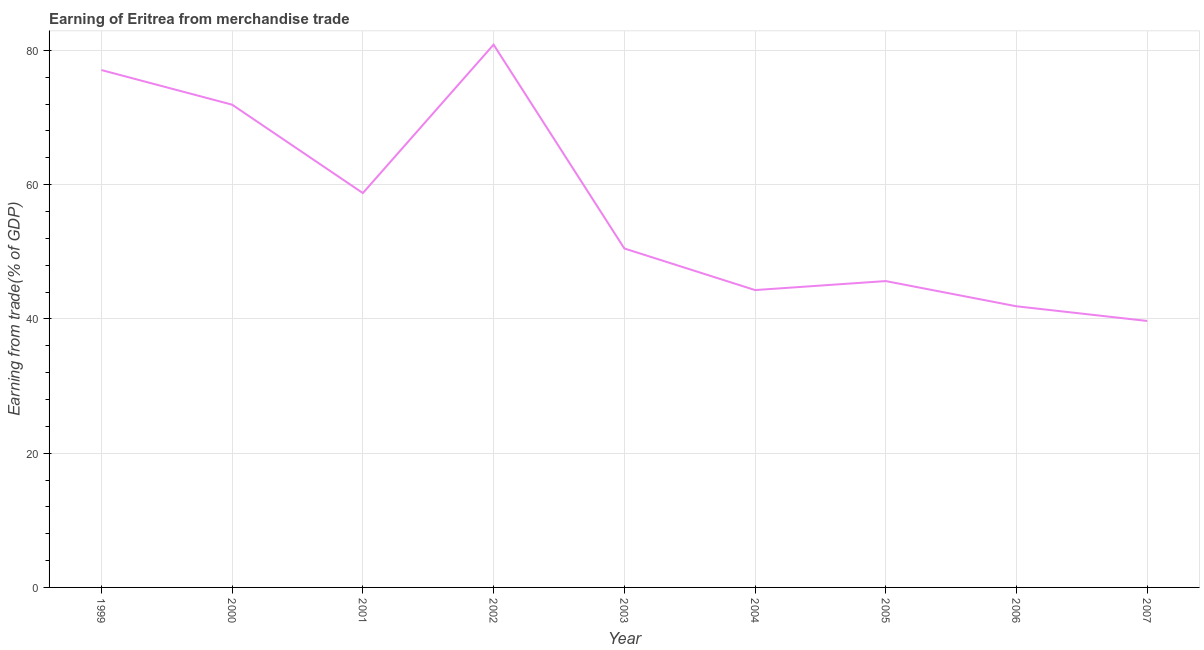What is the earning from merchandise trade in 2007?
Your response must be concise. 39.7. Across all years, what is the maximum earning from merchandise trade?
Keep it short and to the point. 80.86. Across all years, what is the minimum earning from merchandise trade?
Offer a very short reply. 39.7. What is the sum of the earning from merchandise trade?
Provide a short and direct response. 510.62. What is the difference between the earning from merchandise trade in 2003 and 2006?
Make the answer very short. 8.62. What is the average earning from merchandise trade per year?
Offer a very short reply. 56.74. What is the median earning from merchandise trade?
Offer a very short reply. 50.5. What is the ratio of the earning from merchandise trade in 2002 to that in 2005?
Give a very brief answer. 1.77. Is the earning from merchandise trade in 2000 less than that in 2006?
Make the answer very short. No. Is the difference between the earning from merchandise trade in 1999 and 2001 greater than the difference between any two years?
Provide a short and direct response. No. What is the difference between the highest and the second highest earning from merchandise trade?
Your answer should be compact. 3.79. Is the sum of the earning from merchandise trade in 2005 and 2007 greater than the maximum earning from merchandise trade across all years?
Provide a succinct answer. Yes. What is the difference between the highest and the lowest earning from merchandise trade?
Offer a terse response. 41.16. In how many years, is the earning from merchandise trade greater than the average earning from merchandise trade taken over all years?
Your response must be concise. 4. How many years are there in the graph?
Your answer should be compact. 9. What is the difference between two consecutive major ticks on the Y-axis?
Provide a succinct answer. 20. Are the values on the major ticks of Y-axis written in scientific E-notation?
Your answer should be very brief. No. Does the graph contain grids?
Your response must be concise. Yes. What is the title of the graph?
Provide a succinct answer. Earning of Eritrea from merchandise trade. What is the label or title of the X-axis?
Ensure brevity in your answer.  Year. What is the label or title of the Y-axis?
Provide a short and direct response. Earning from trade(% of GDP). What is the Earning from trade(% of GDP) in 1999?
Ensure brevity in your answer.  77.08. What is the Earning from trade(% of GDP) in 2000?
Your answer should be compact. 71.92. What is the Earning from trade(% of GDP) of 2001?
Offer a very short reply. 58.75. What is the Earning from trade(% of GDP) in 2002?
Keep it short and to the point. 80.86. What is the Earning from trade(% of GDP) of 2003?
Offer a very short reply. 50.5. What is the Earning from trade(% of GDP) of 2004?
Provide a short and direct response. 44.3. What is the Earning from trade(% of GDP) of 2005?
Make the answer very short. 45.64. What is the Earning from trade(% of GDP) in 2006?
Offer a terse response. 41.88. What is the Earning from trade(% of GDP) of 2007?
Offer a very short reply. 39.7. What is the difference between the Earning from trade(% of GDP) in 1999 and 2000?
Ensure brevity in your answer.  5.16. What is the difference between the Earning from trade(% of GDP) in 1999 and 2001?
Make the answer very short. 18.33. What is the difference between the Earning from trade(% of GDP) in 1999 and 2002?
Give a very brief answer. -3.79. What is the difference between the Earning from trade(% of GDP) in 1999 and 2003?
Your answer should be very brief. 26.58. What is the difference between the Earning from trade(% of GDP) in 1999 and 2004?
Make the answer very short. 32.78. What is the difference between the Earning from trade(% of GDP) in 1999 and 2005?
Your answer should be compact. 31.44. What is the difference between the Earning from trade(% of GDP) in 1999 and 2006?
Provide a succinct answer. 35.19. What is the difference between the Earning from trade(% of GDP) in 1999 and 2007?
Provide a short and direct response. 37.38. What is the difference between the Earning from trade(% of GDP) in 2000 and 2001?
Make the answer very short. 13.17. What is the difference between the Earning from trade(% of GDP) in 2000 and 2002?
Provide a succinct answer. -8.95. What is the difference between the Earning from trade(% of GDP) in 2000 and 2003?
Offer a terse response. 21.42. What is the difference between the Earning from trade(% of GDP) in 2000 and 2004?
Ensure brevity in your answer.  27.62. What is the difference between the Earning from trade(% of GDP) in 2000 and 2005?
Ensure brevity in your answer.  26.28. What is the difference between the Earning from trade(% of GDP) in 2000 and 2006?
Make the answer very short. 30.03. What is the difference between the Earning from trade(% of GDP) in 2000 and 2007?
Provide a short and direct response. 32.22. What is the difference between the Earning from trade(% of GDP) in 2001 and 2002?
Make the answer very short. -22.12. What is the difference between the Earning from trade(% of GDP) in 2001 and 2003?
Provide a short and direct response. 8.25. What is the difference between the Earning from trade(% of GDP) in 2001 and 2004?
Keep it short and to the point. 14.45. What is the difference between the Earning from trade(% of GDP) in 2001 and 2005?
Your answer should be very brief. 13.11. What is the difference between the Earning from trade(% of GDP) in 2001 and 2006?
Provide a succinct answer. 16.86. What is the difference between the Earning from trade(% of GDP) in 2001 and 2007?
Provide a short and direct response. 19.05. What is the difference between the Earning from trade(% of GDP) in 2002 and 2003?
Offer a very short reply. 30.37. What is the difference between the Earning from trade(% of GDP) in 2002 and 2004?
Ensure brevity in your answer.  36.56. What is the difference between the Earning from trade(% of GDP) in 2002 and 2005?
Ensure brevity in your answer.  35.22. What is the difference between the Earning from trade(% of GDP) in 2002 and 2006?
Make the answer very short. 38.98. What is the difference between the Earning from trade(% of GDP) in 2002 and 2007?
Provide a short and direct response. 41.16. What is the difference between the Earning from trade(% of GDP) in 2003 and 2004?
Provide a short and direct response. 6.2. What is the difference between the Earning from trade(% of GDP) in 2003 and 2005?
Offer a terse response. 4.86. What is the difference between the Earning from trade(% of GDP) in 2003 and 2006?
Your answer should be very brief. 8.62. What is the difference between the Earning from trade(% of GDP) in 2003 and 2007?
Give a very brief answer. 10.8. What is the difference between the Earning from trade(% of GDP) in 2004 and 2005?
Ensure brevity in your answer.  -1.34. What is the difference between the Earning from trade(% of GDP) in 2004 and 2006?
Keep it short and to the point. 2.42. What is the difference between the Earning from trade(% of GDP) in 2004 and 2007?
Your answer should be very brief. 4.6. What is the difference between the Earning from trade(% of GDP) in 2005 and 2006?
Your answer should be very brief. 3.76. What is the difference between the Earning from trade(% of GDP) in 2005 and 2007?
Your answer should be compact. 5.94. What is the difference between the Earning from trade(% of GDP) in 2006 and 2007?
Offer a terse response. 2.18. What is the ratio of the Earning from trade(% of GDP) in 1999 to that in 2000?
Your response must be concise. 1.07. What is the ratio of the Earning from trade(% of GDP) in 1999 to that in 2001?
Ensure brevity in your answer.  1.31. What is the ratio of the Earning from trade(% of GDP) in 1999 to that in 2002?
Keep it short and to the point. 0.95. What is the ratio of the Earning from trade(% of GDP) in 1999 to that in 2003?
Keep it short and to the point. 1.53. What is the ratio of the Earning from trade(% of GDP) in 1999 to that in 2004?
Make the answer very short. 1.74. What is the ratio of the Earning from trade(% of GDP) in 1999 to that in 2005?
Offer a terse response. 1.69. What is the ratio of the Earning from trade(% of GDP) in 1999 to that in 2006?
Your response must be concise. 1.84. What is the ratio of the Earning from trade(% of GDP) in 1999 to that in 2007?
Provide a short and direct response. 1.94. What is the ratio of the Earning from trade(% of GDP) in 2000 to that in 2001?
Give a very brief answer. 1.22. What is the ratio of the Earning from trade(% of GDP) in 2000 to that in 2002?
Give a very brief answer. 0.89. What is the ratio of the Earning from trade(% of GDP) in 2000 to that in 2003?
Make the answer very short. 1.42. What is the ratio of the Earning from trade(% of GDP) in 2000 to that in 2004?
Give a very brief answer. 1.62. What is the ratio of the Earning from trade(% of GDP) in 2000 to that in 2005?
Make the answer very short. 1.58. What is the ratio of the Earning from trade(% of GDP) in 2000 to that in 2006?
Give a very brief answer. 1.72. What is the ratio of the Earning from trade(% of GDP) in 2000 to that in 2007?
Your answer should be very brief. 1.81. What is the ratio of the Earning from trade(% of GDP) in 2001 to that in 2002?
Provide a succinct answer. 0.73. What is the ratio of the Earning from trade(% of GDP) in 2001 to that in 2003?
Provide a succinct answer. 1.16. What is the ratio of the Earning from trade(% of GDP) in 2001 to that in 2004?
Offer a terse response. 1.33. What is the ratio of the Earning from trade(% of GDP) in 2001 to that in 2005?
Keep it short and to the point. 1.29. What is the ratio of the Earning from trade(% of GDP) in 2001 to that in 2006?
Keep it short and to the point. 1.4. What is the ratio of the Earning from trade(% of GDP) in 2001 to that in 2007?
Your response must be concise. 1.48. What is the ratio of the Earning from trade(% of GDP) in 2002 to that in 2003?
Your answer should be compact. 1.6. What is the ratio of the Earning from trade(% of GDP) in 2002 to that in 2004?
Offer a very short reply. 1.82. What is the ratio of the Earning from trade(% of GDP) in 2002 to that in 2005?
Give a very brief answer. 1.77. What is the ratio of the Earning from trade(% of GDP) in 2002 to that in 2006?
Provide a short and direct response. 1.93. What is the ratio of the Earning from trade(% of GDP) in 2002 to that in 2007?
Ensure brevity in your answer.  2.04. What is the ratio of the Earning from trade(% of GDP) in 2003 to that in 2004?
Offer a terse response. 1.14. What is the ratio of the Earning from trade(% of GDP) in 2003 to that in 2005?
Keep it short and to the point. 1.11. What is the ratio of the Earning from trade(% of GDP) in 2003 to that in 2006?
Make the answer very short. 1.21. What is the ratio of the Earning from trade(% of GDP) in 2003 to that in 2007?
Your answer should be very brief. 1.27. What is the ratio of the Earning from trade(% of GDP) in 2004 to that in 2005?
Ensure brevity in your answer.  0.97. What is the ratio of the Earning from trade(% of GDP) in 2004 to that in 2006?
Offer a very short reply. 1.06. What is the ratio of the Earning from trade(% of GDP) in 2004 to that in 2007?
Offer a very short reply. 1.12. What is the ratio of the Earning from trade(% of GDP) in 2005 to that in 2006?
Provide a succinct answer. 1.09. What is the ratio of the Earning from trade(% of GDP) in 2005 to that in 2007?
Give a very brief answer. 1.15. What is the ratio of the Earning from trade(% of GDP) in 2006 to that in 2007?
Your response must be concise. 1.05. 